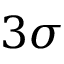Convert formula to latex. <formula><loc_0><loc_0><loc_500><loc_500>3 \sigma</formula> 